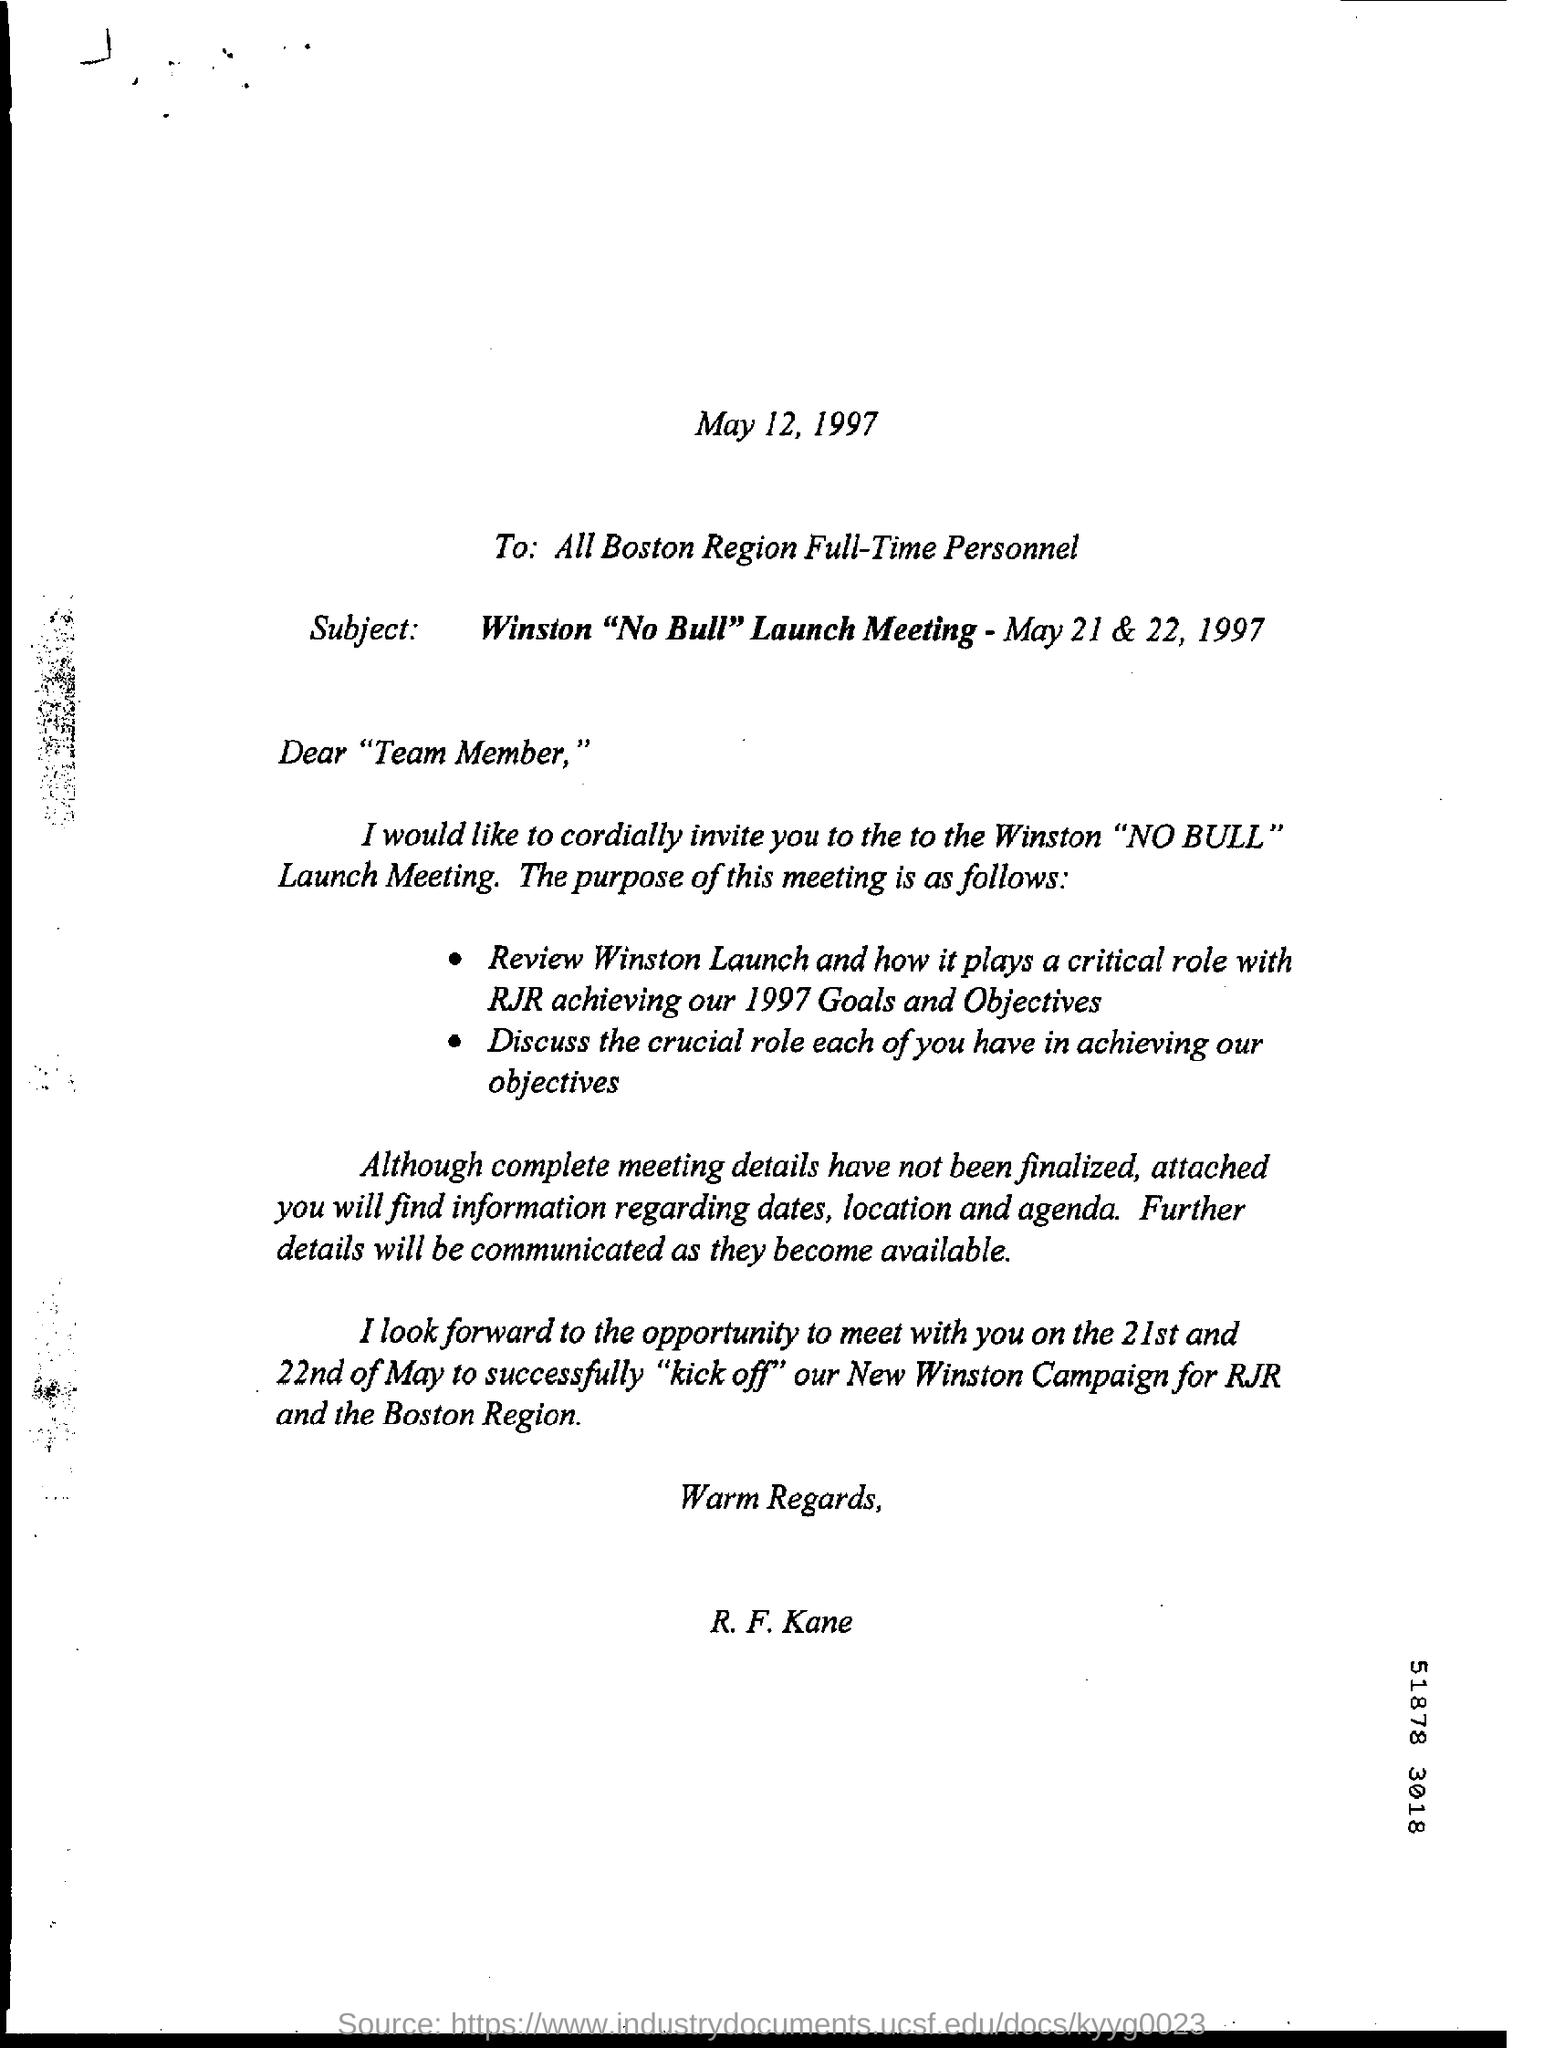Highlight a few significant elements in this photo. All Boston Region full-time personnel have written in the field. The date mentioned in the subject line is May 21 & 22, 1997. The date mentioned at the top of the document is May 12, 1997. 